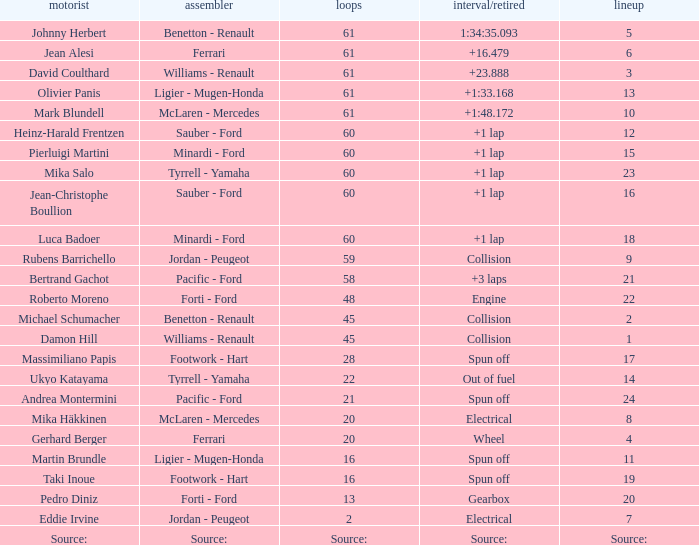How many laps does jean-christophe boullion have with a time/retired of +1 lap? 60.0. 